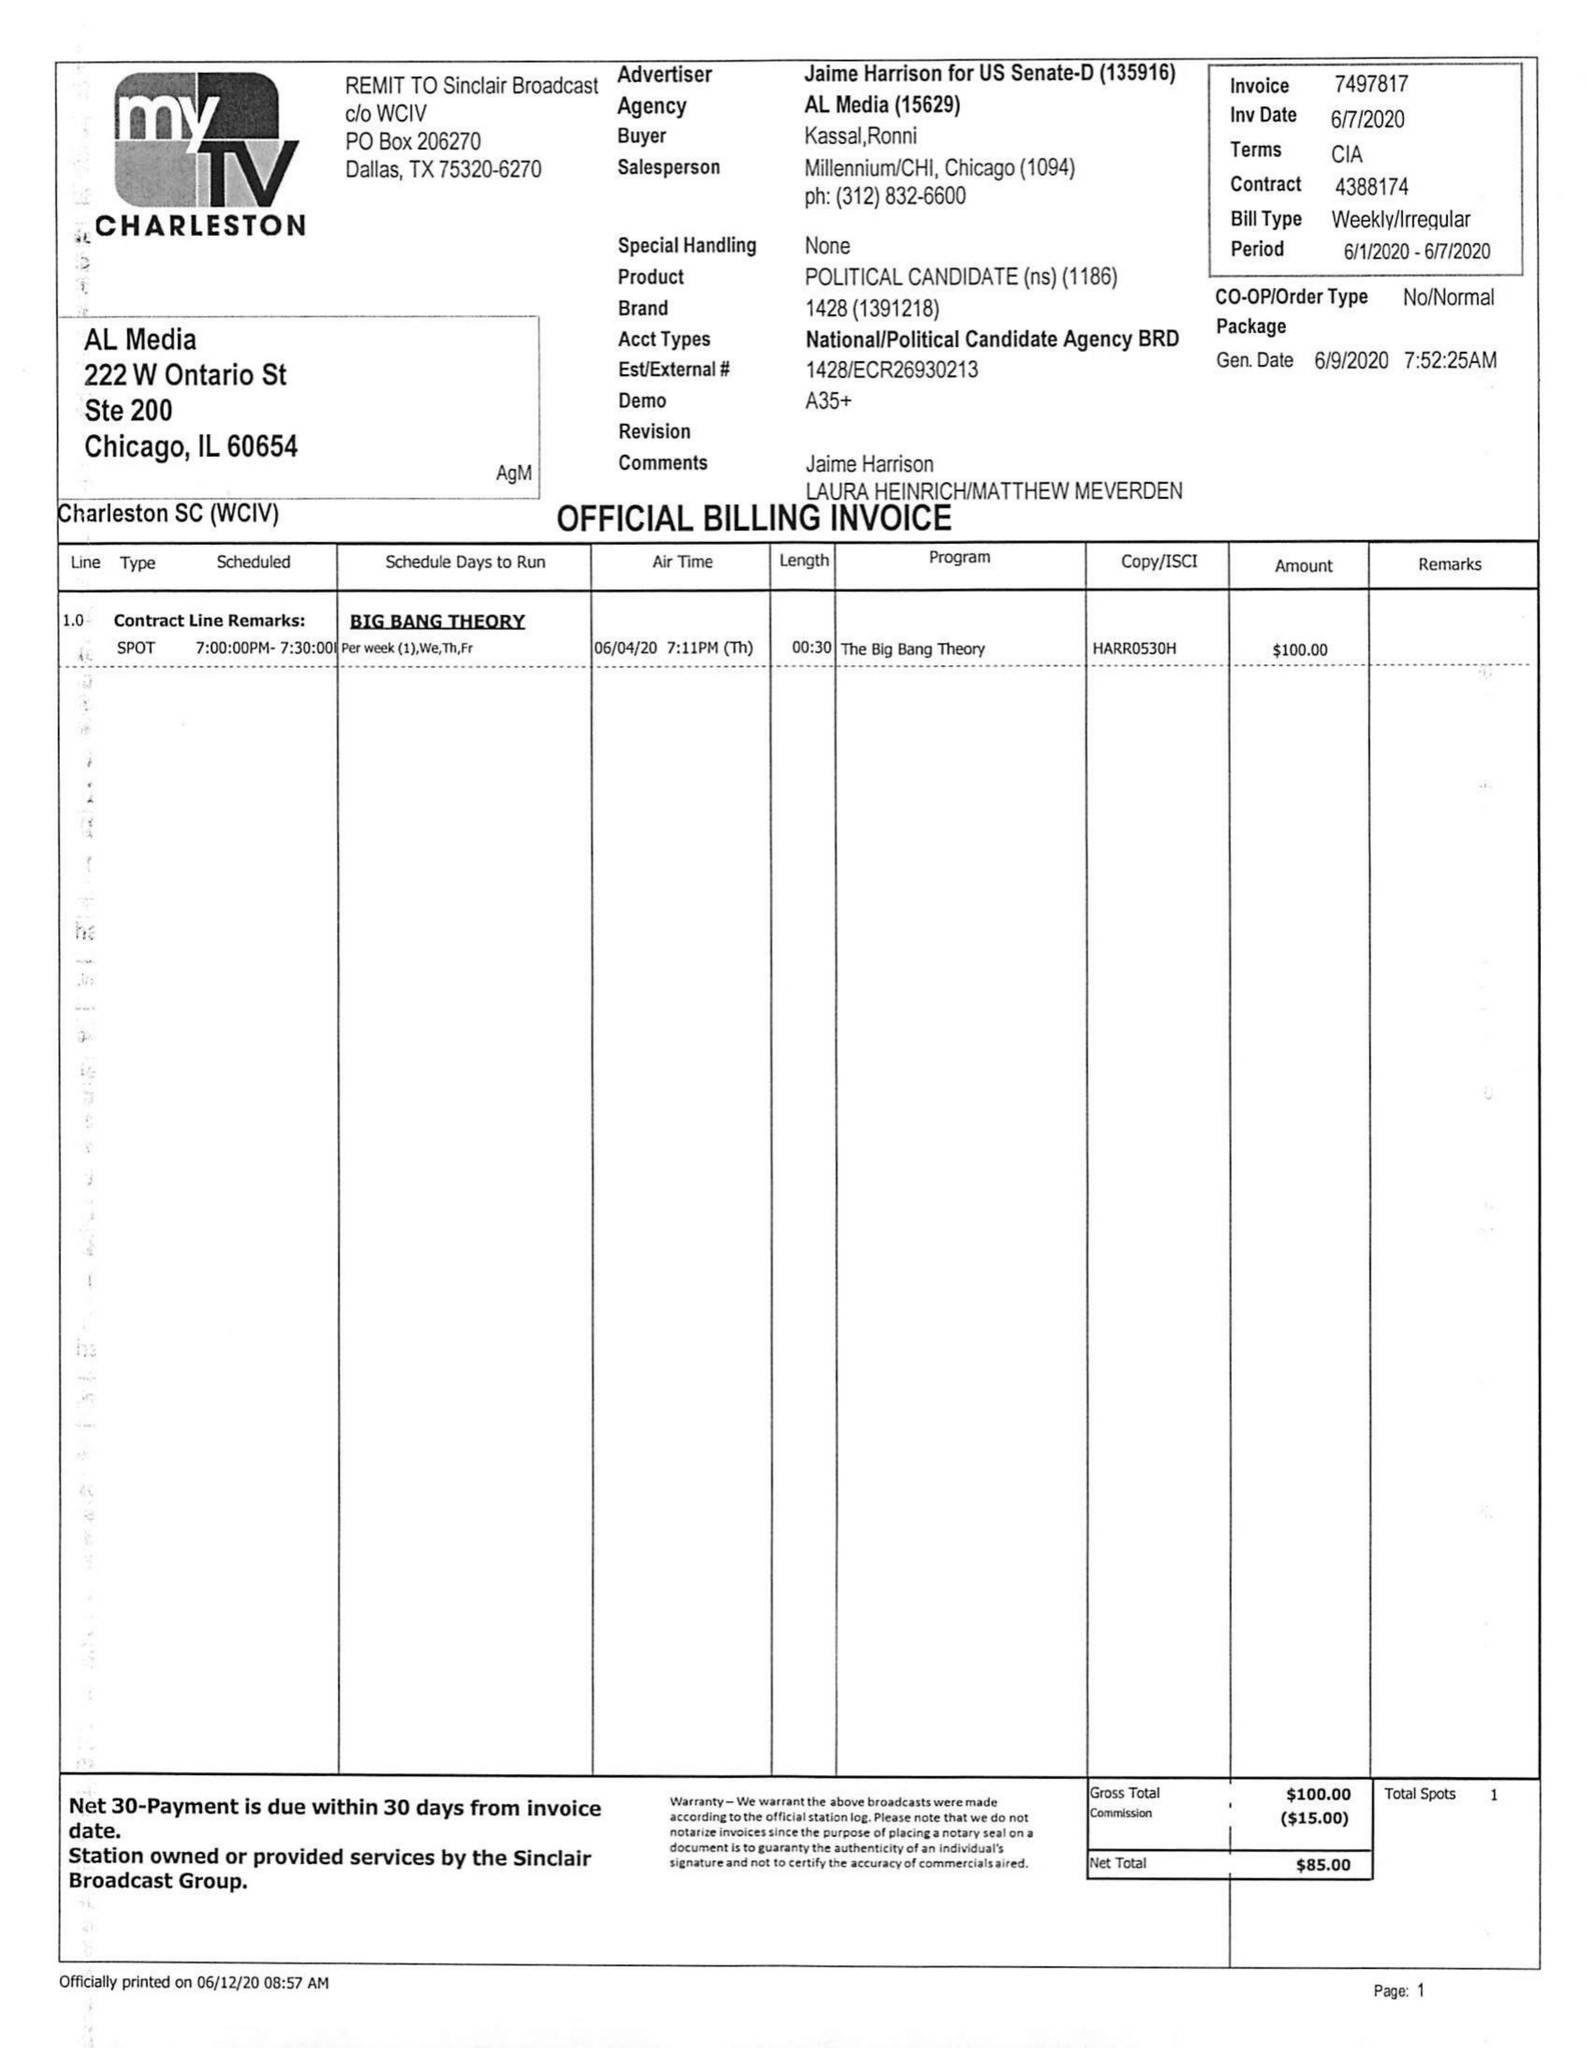What is the value for the advertiser?
Answer the question using a single word or phrase. JAIME HARRISON FOR US SENATE-D 